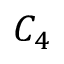Convert formula to latex. <formula><loc_0><loc_0><loc_500><loc_500>C _ { 4 }</formula> 